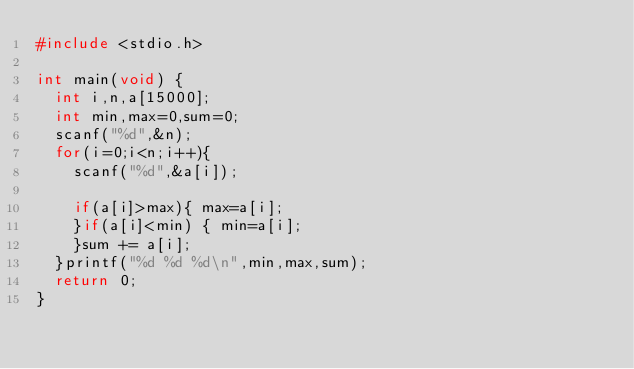Convert code to text. <code><loc_0><loc_0><loc_500><loc_500><_C_>#include <stdio.h>

int main(void) {
	int i,n,a[15000];
	int min,max=0,sum=0;
	scanf("%d",&n);
	for(i=0;i<n;i++){
		scanf("%d",&a[i]);
	
		if(a[i]>max){ max=a[i];
		}if(a[i]<min) { min=a[i];
		}sum += a[i];
	}printf("%d %d %d\n",min,max,sum);
	return 0;
}</code> 